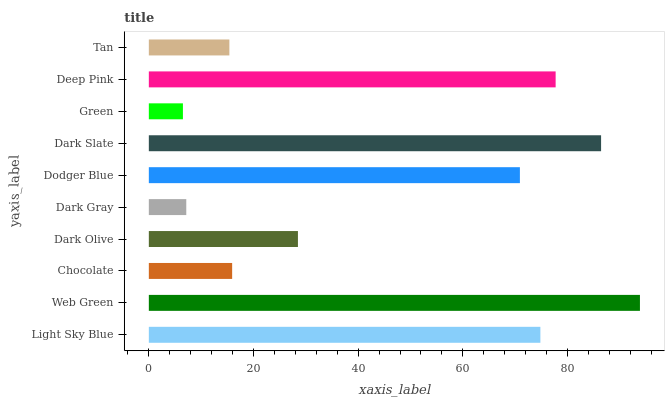Is Green the minimum?
Answer yes or no. Yes. Is Web Green the maximum?
Answer yes or no. Yes. Is Chocolate the minimum?
Answer yes or no. No. Is Chocolate the maximum?
Answer yes or no. No. Is Web Green greater than Chocolate?
Answer yes or no. Yes. Is Chocolate less than Web Green?
Answer yes or no. Yes. Is Chocolate greater than Web Green?
Answer yes or no. No. Is Web Green less than Chocolate?
Answer yes or no. No. Is Dodger Blue the high median?
Answer yes or no. Yes. Is Dark Olive the low median?
Answer yes or no. Yes. Is Light Sky Blue the high median?
Answer yes or no. No. Is Chocolate the low median?
Answer yes or no. No. 